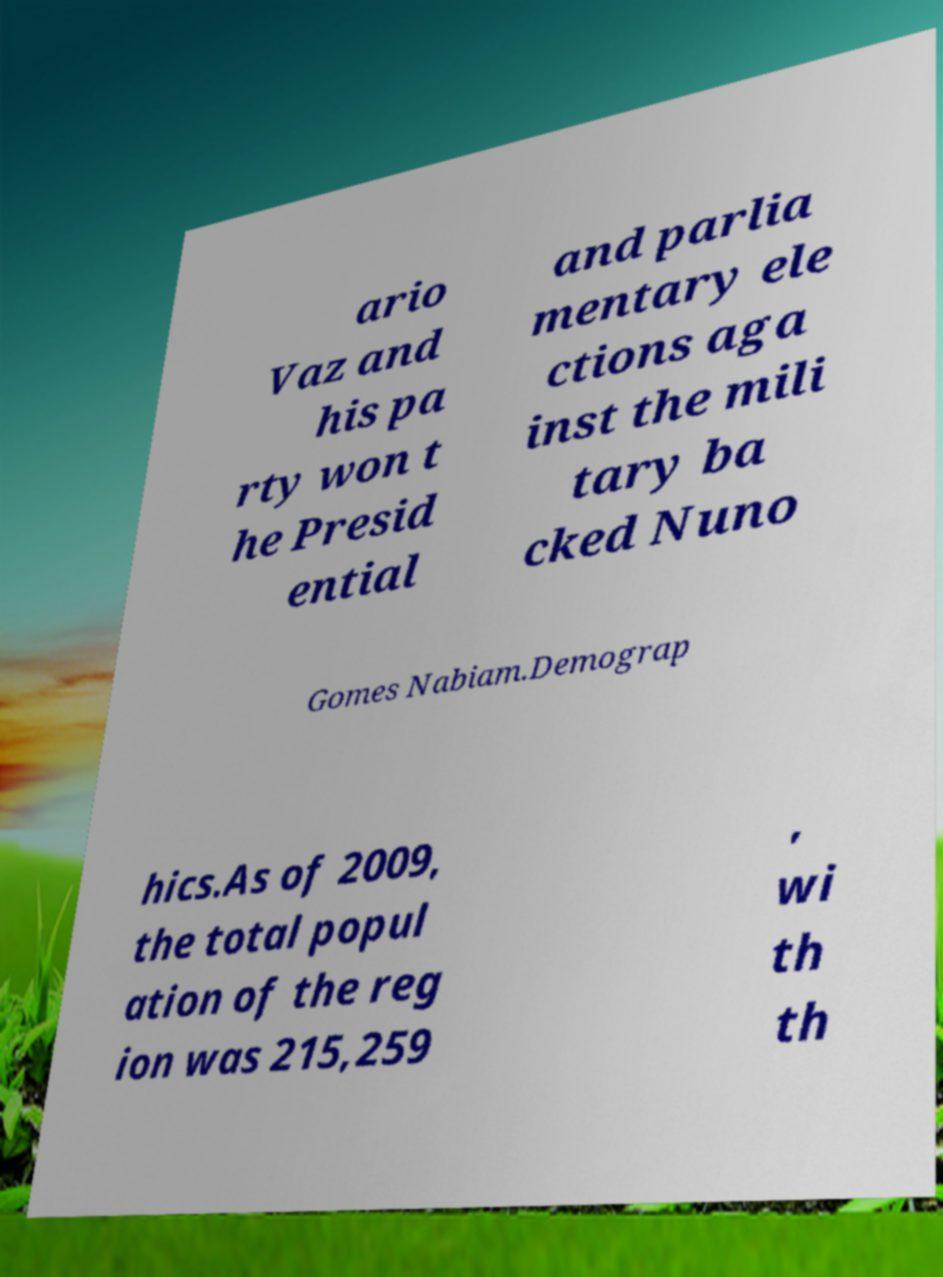Please identify and transcribe the text found in this image. ario Vaz and his pa rty won t he Presid ential and parlia mentary ele ctions aga inst the mili tary ba cked Nuno Gomes Nabiam.Demograp hics.As of 2009, the total popul ation of the reg ion was 215,259 , wi th th 